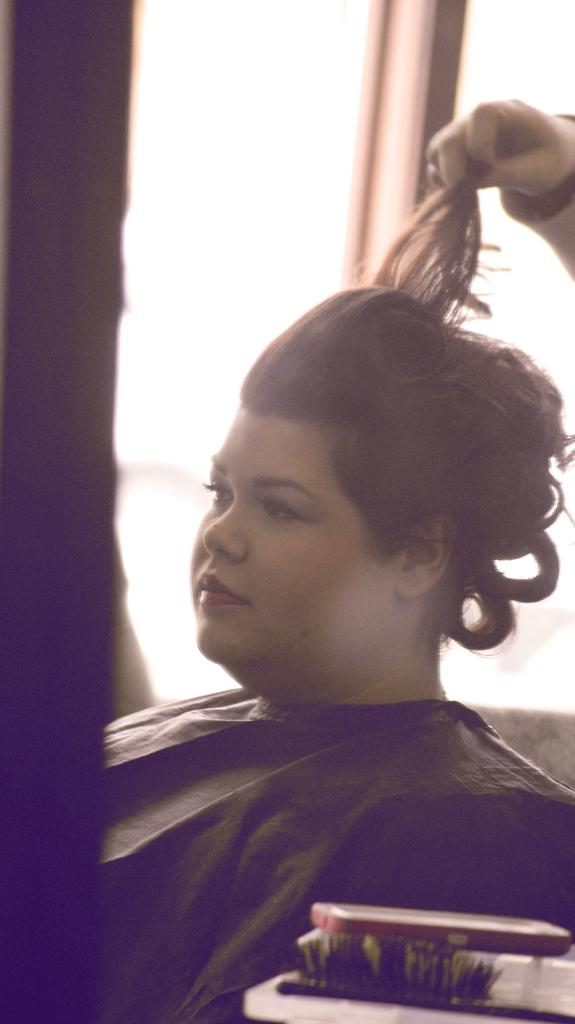Who is present in the image? There is a woman in the image. What is the woman wearing? The woman is wearing a black dress. What object can be seen in the image? There is a brush in the image. What architectural feature is visible in the image? There are windows in the image. What type of camp can be seen in the image? There is no camp present in the image. How does the woman stretch her arms in the image? The image does not show the woman stretching her arms; she is simply standing or posing. 